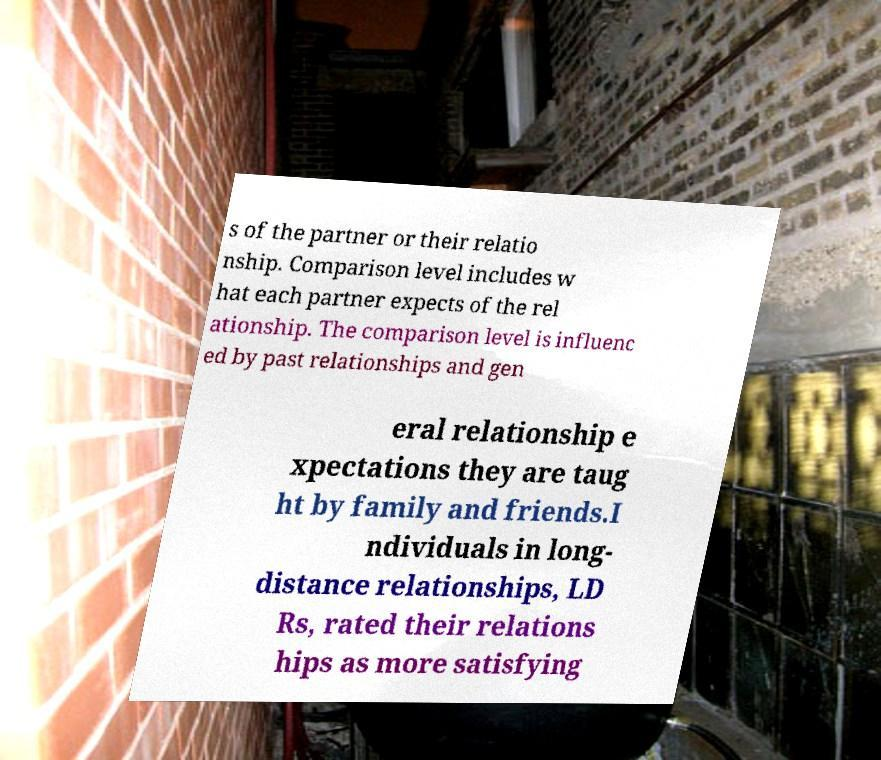Please read and relay the text visible in this image. What does it say? s of the partner or their relatio nship. Comparison level includes w hat each partner expects of the rel ationship. The comparison level is influenc ed by past relationships and gen eral relationship e xpectations they are taug ht by family and friends.I ndividuals in long- distance relationships, LD Rs, rated their relations hips as more satisfying 